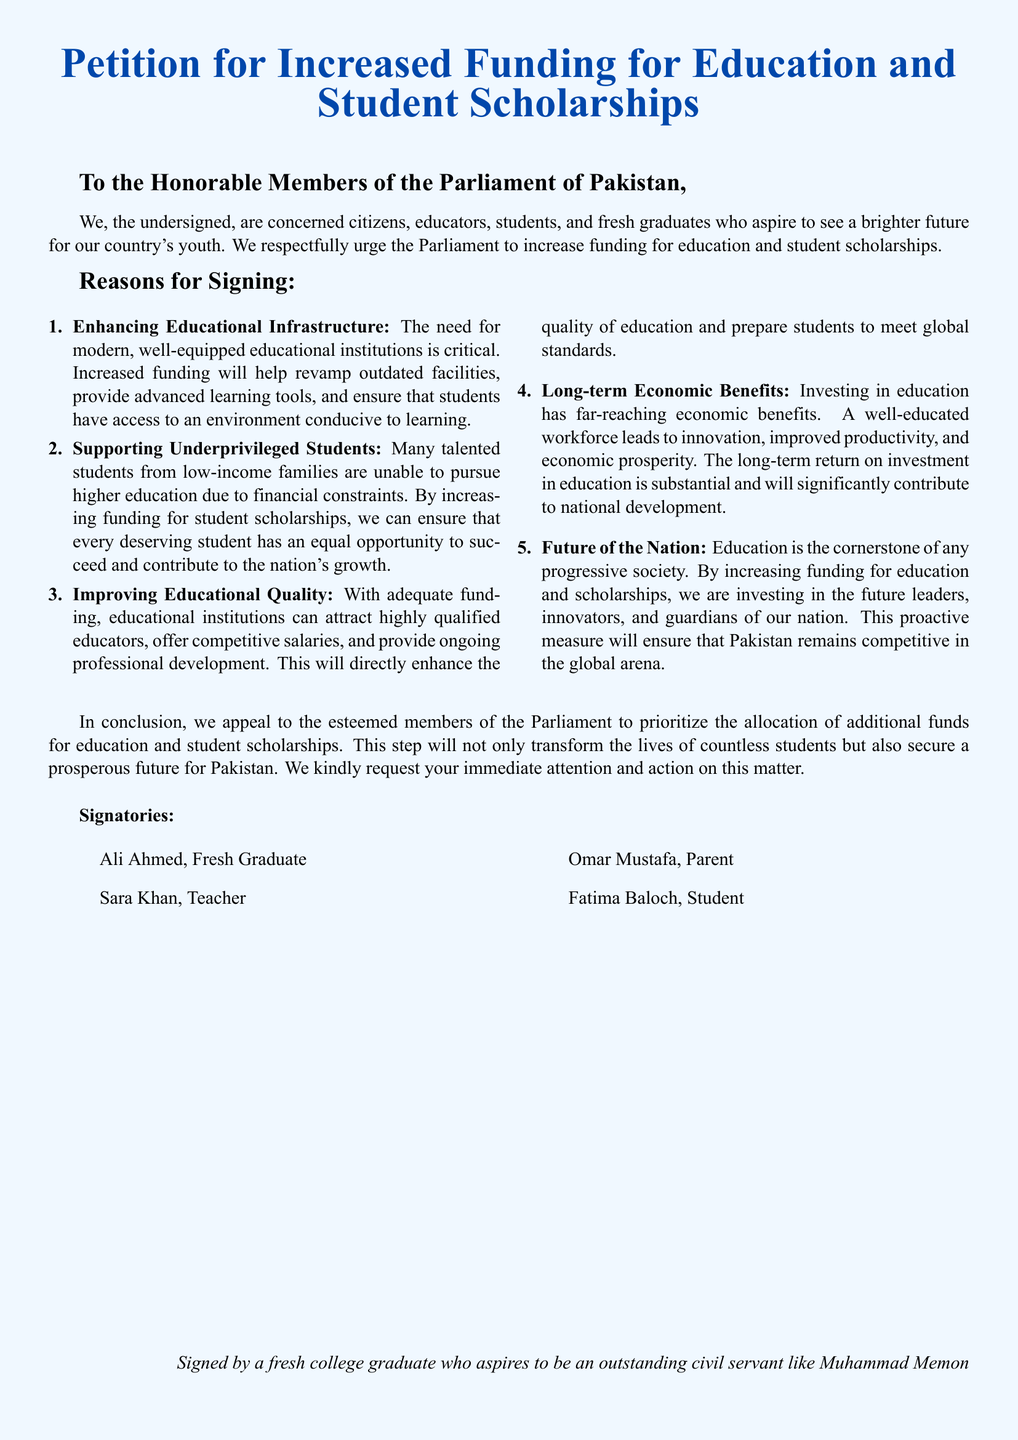What is the title of the petition? The title of the petition is prominently stated at the beginning of the document.
Answer: Petition for Increased Funding for Education and Student Scholarships Who is the petition addressed to? The petition is directed towards the members of the Parliament of a specific country.
Answer: The Honorable Members of the Parliament of Pakistan How many reasons for signing are listed? The reasons for signing the petition are enumerated in a list format within the document.
Answer: Five What is one reason mentioned for increased funding? Specific reasons for increased funding are detailed, highlighting various aspects of education.
Answer: Enhancing Educational Infrastructure What type of individuals signed the petition? The signatories are identified in a list at the end of the document, representing a mix of people.
Answer: Educators, students, and fresh graduates What is one of the long-term benefits of investing in education mentioned? The document outlines economic advantages as a result of increased education funding.
Answer: Long-term Economic Benefits Who is a notable signatory's role mentioned in the document? The signatories include individuals from various professions; their roles are briefly identified.
Answer: Fresh Graduate What color is used for the document background? The background color is specified in the document, contributing to its visual appeal.
Answer: Light Blue 